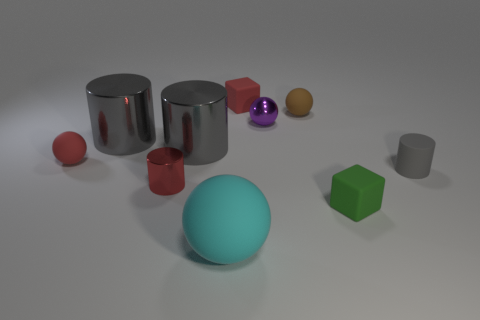The matte sphere that is the same color as the small shiny cylinder is what size?
Your answer should be very brief. Small. Is the small gray rubber object the same shape as the green matte object?
Give a very brief answer. No. How many objects are either small things in front of the gray rubber object or big objects?
Your answer should be compact. 5. Are there the same number of small brown matte spheres on the right side of the small gray object and tiny balls on the left side of the large cyan object?
Ensure brevity in your answer.  No. How many other objects are the same shape as the red metal thing?
Provide a succinct answer. 3. Does the matte thing that is to the left of the big cyan ball have the same size as the purple object on the right side of the tiny red metallic object?
Make the answer very short. Yes. What number of balls are tiny red objects or tiny gray rubber things?
Ensure brevity in your answer.  1. How many metallic things are either tiny brown balls or red spheres?
Ensure brevity in your answer.  0. What size is the other object that is the same shape as the tiny green rubber object?
Offer a terse response. Small. Is there any other thing that is the same size as the purple metal thing?
Give a very brief answer. Yes. 